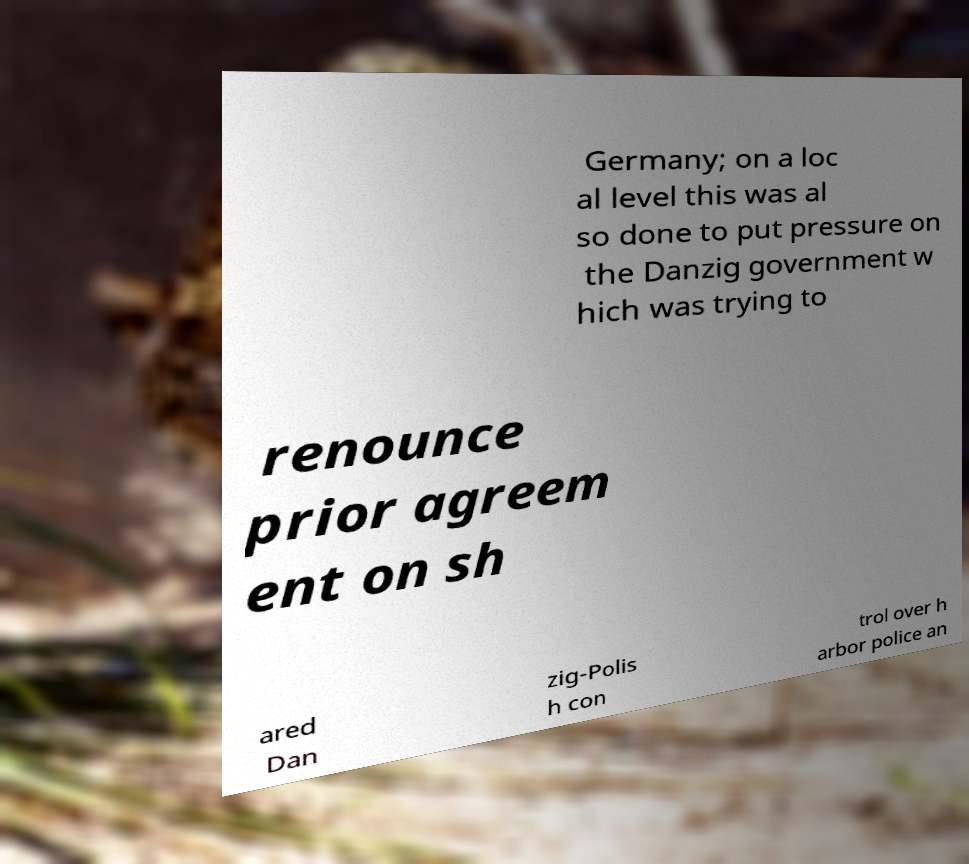What messages or text are displayed in this image? I need them in a readable, typed format. Germany; on a loc al level this was al so done to put pressure on the Danzig government w hich was trying to renounce prior agreem ent on sh ared Dan zig-Polis h con trol over h arbor police an 